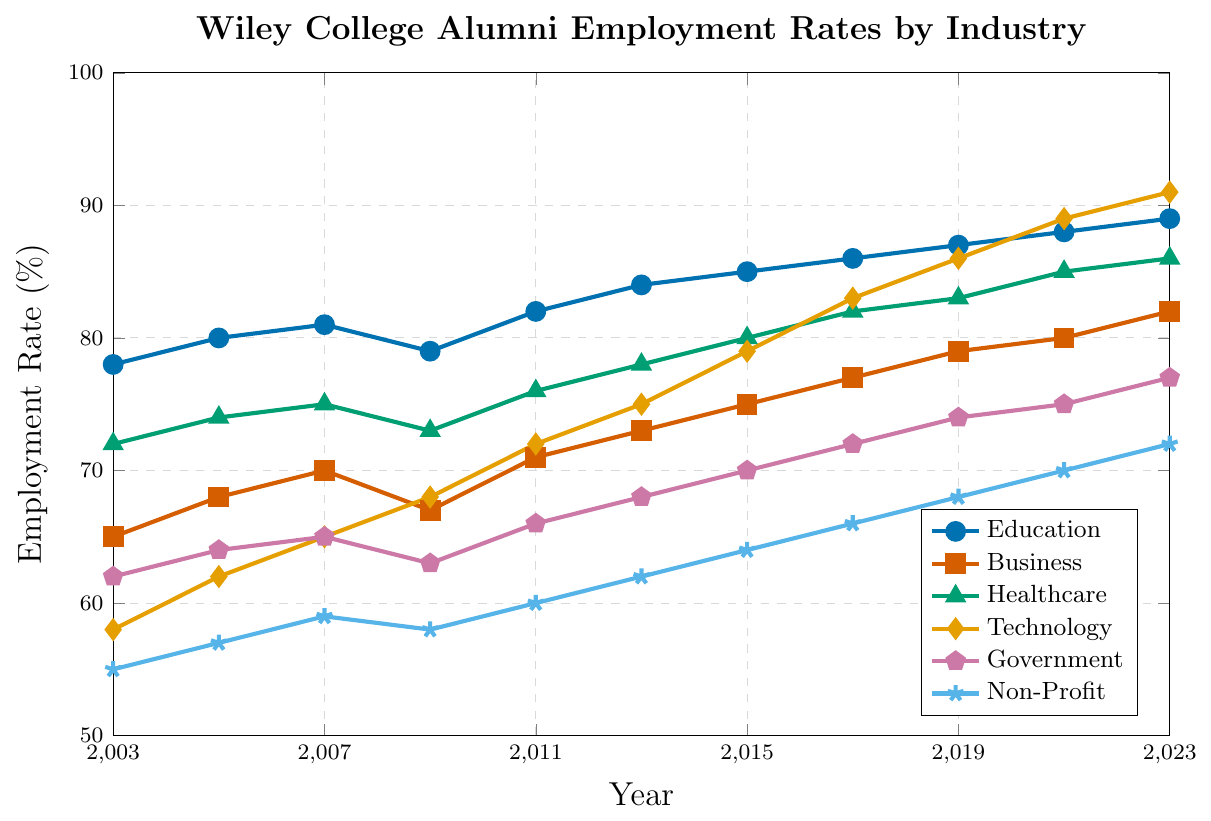Which industry had the highest employment rate in 2023? In 2023, the employment rates for each industry can be compared by their values on the y-axis. Technology had the highest employment rate at 91%.
Answer: Technology What is the percentage increase in employment rate in the Technology sector from 2003 to 2023? In 2003, the Technology employment rate was 58%. By 2023, it increased to 91%. The percentage increase is calculated as ((91-58)/58) * 100 = 56.9%.
Answer: 56.9% Which industry showed the least change in employment rates over the 20 years? By comparing the starting (2003) and ending (2023) values, Government increased from 62% to 77%, showing an increase of 15 percentage points, which is less than the changes in other industries.
Answer: Government On average, how much did the Healthcare employment rate change per year from 2003 to 2023? The Healthcare employment rate increased from 72% in 2003 to 86% in 2023, resulting in a total change of 14 percentage points over 20 years. The average yearly change is 14/20 = 0.7 percentage points/year.
Answer: 0.7 percentage points/year Among the industries, which had the lowest employment rate in 2015? By checking the y-axis values for each industry in 2015, the Non-Profit sector had the lowest employment rate at 64%.
Answer: Non-Profit Between 2003 and 2023, which industry experienced the highest increase in employment rates? Calculating the difference between 2023 and 2003 employment rates for each industry, Technology had the highest increase ((91-58)=33 percentage points).
Answer: Technology How did the trend in employment rates for the Education sector compare to the trend in the Business sector over the 20 years? Both sectors show an increasing trend in employment rates from 2003 to 2023. Education increased from 78% to 89%, while Business increased from 65% to 82%. The Education sector experienced a more consistent upward trend.
Answer: Education had a more consistent upward trend Which sectors had employment rates exceeding 80% by 2023? Checking all sectors in 2023, Education (89%), Business (82%), Healthcare (86%), Technology (91%), and Government (77%) are checked. Non-Profit reached 72%. So, Education, Business, Healthcare, and Technology exceed 80%.
Answer: Education, Business, Healthcare, Technology What can be inferred about the employment rate trends in the Non-Profit sector from 2009 to 2013? Between 2009 (58%) and 2013 (62%), the Non-Profit sector's employment rate shows a steady increase (4 percentage points) over the period.
Answer: Steady increase Compare the Government and Non-Profit employment rates in 2021. Which sector had a higher employment rate, and by how much? In 2021, the Government employment rate was 75%, and the Non-Profit employment rate was 70%. Government's rate was higher by 5 percentage points.
Answer: Government, by 5 percentage points 